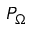<formula> <loc_0><loc_0><loc_500><loc_500>P _ { \Omega }</formula> 